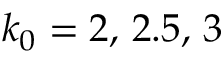Convert formula to latex. <formula><loc_0><loc_0><loc_500><loc_500>k _ { 0 } = 2 , \, 2 . 5 , \, 3</formula> 